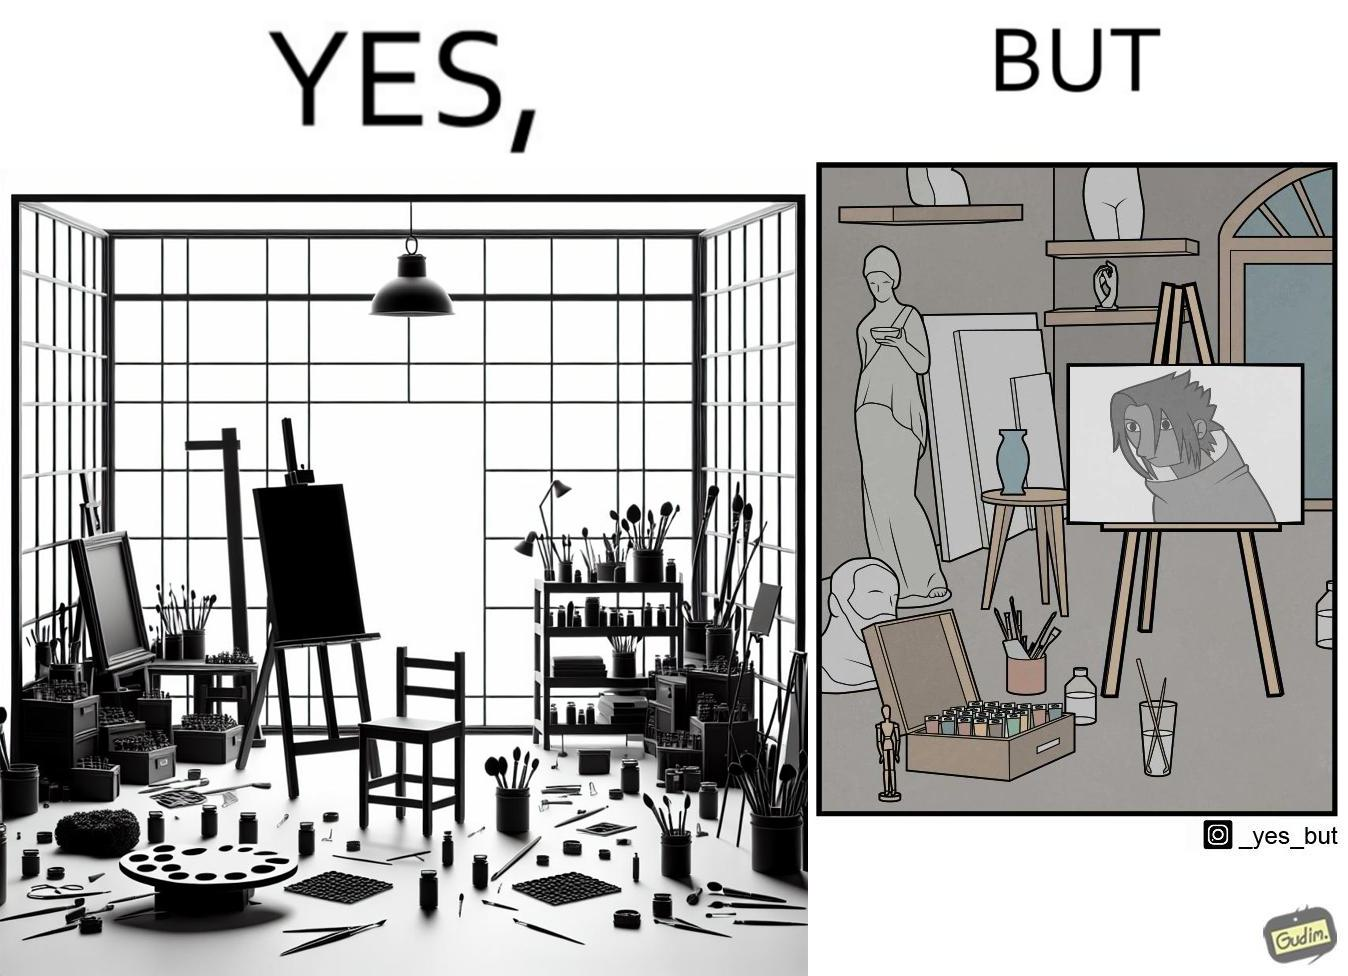Is this image satirical or non-satirical? Yes, this image is satirical. 